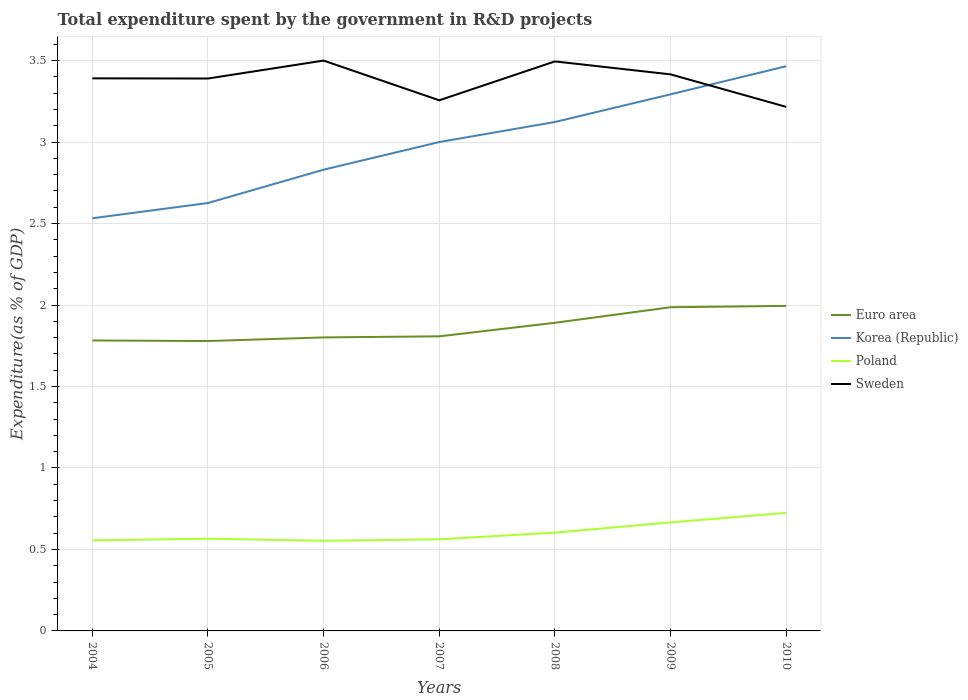How many different coloured lines are there?
Ensure brevity in your answer.  4. Does the line corresponding to Sweden intersect with the line corresponding to Poland?
Your response must be concise. No. Is the number of lines equal to the number of legend labels?
Offer a very short reply. Yes. Across all years, what is the maximum total expenditure spent by the government in R&D projects in Korea (Republic)?
Make the answer very short. 2.53. In which year was the total expenditure spent by the government in R&D projects in Euro area maximum?
Give a very brief answer. 2005. What is the total total expenditure spent by the government in R&D projects in Korea (Republic) in the graph?
Offer a very short reply. -0.17. What is the difference between the highest and the second highest total expenditure spent by the government in R&D projects in Euro area?
Your answer should be compact. 0.22. What is the difference between the highest and the lowest total expenditure spent by the government in R&D projects in Sweden?
Provide a short and direct response. 5. Is the total expenditure spent by the government in R&D projects in Korea (Republic) strictly greater than the total expenditure spent by the government in R&D projects in Sweden over the years?
Make the answer very short. No. How many lines are there?
Make the answer very short. 4. Does the graph contain grids?
Make the answer very short. Yes. Where does the legend appear in the graph?
Offer a terse response. Center right. How many legend labels are there?
Your response must be concise. 4. What is the title of the graph?
Keep it short and to the point. Total expenditure spent by the government in R&D projects. Does "East Asia (developing only)" appear as one of the legend labels in the graph?
Provide a short and direct response. No. What is the label or title of the X-axis?
Ensure brevity in your answer.  Years. What is the label or title of the Y-axis?
Keep it short and to the point. Expenditure(as % of GDP). What is the Expenditure(as % of GDP) in Euro area in 2004?
Ensure brevity in your answer.  1.78. What is the Expenditure(as % of GDP) in Korea (Republic) in 2004?
Your answer should be very brief. 2.53. What is the Expenditure(as % of GDP) in Poland in 2004?
Keep it short and to the point. 0.56. What is the Expenditure(as % of GDP) in Sweden in 2004?
Your answer should be compact. 3.39. What is the Expenditure(as % of GDP) in Euro area in 2005?
Keep it short and to the point. 1.78. What is the Expenditure(as % of GDP) of Korea (Republic) in 2005?
Offer a very short reply. 2.63. What is the Expenditure(as % of GDP) in Poland in 2005?
Offer a terse response. 0.57. What is the Expenditure(as % of GDP) of Sweden in 2005?
Provide a short and direct response. 3.39. What is the Expenditure(as % of GDP) of Euro area in 2006?
Your response must be concise. 1.8. What is the Expenditure(as % of GDP) of Korea (Republic) in 2006?
Make the answer very short. 2.83. What is the Expenditure(as % of GDP) of Poland in 2006?
Give a very brief answer. 0.55. What is the Expenditure(as % of GDP) of Sweden in 2006?
Provide a succinct answer. 3.5. What is the Expenditure(as % of GDP) in Euro area in 2007?
Your answer should be very brief. 1.81. What is the Expenditure(as % of GDP) of Korea (Republic) in 2007?
Offer a very short reply. 3. What is the Expenditure(as % of GDP) in Poland in 2007?
Your answer should be very brief. 0.56. What is the Expenditure(as % of GDP) in Sweden in 2007?
Keep it short and to the point. 3.26. What is the Expenditure(as % of GDP) in Euro area in 2008?
Provide a succinct answer. 1.89. What is the Expenditure(as % of GDP) of Korea (Republic) in 2008?
Make the answer very short. 3.12. What is the Expenditure(as % of GDP) in Poland in 2008?
Provide a succinct answer. 0.6. What is the Expenditure(as % of GDP) of Sweden in 2008?
Provide a succinct answer. 3.5. What is the Expenditure(as % of GDP) of Euro area in 2009?
Give a very brief answer. 1.99. What is the Expenditure(as % of GDP) of Korea (Republic) in 2009?
Your answer should be very brief. 3.29. What is the Expenditure(as % of GDP) in Poland in 2009?
Provide a short and direct response. 0.67. What is the Expenditure(as % of GDP) in Sweden in 2009?
Make the answer very short. 3.42. What is the Expenditure(as % of GDP) in Euro area in 2010?
Provide a short and direct response. 1.99. What is the Expenditure(as % of GDP) of Korea (Republic) in 2010?
Keep it short and to the point. 3.47. What is the Expenditure(as % of GDP) in Poland in 2010?
Give a very brief answer. 0.72. What is the Expenditure(as % of GDP) in Sweden in 2010?
Your answer should be compact. 3.22. Across all years, what is the maximum Expenditure(as % of GDP) in Euro area?
Your answer should be compact. 1.99. Across all years, what is the maximum Expenditure(as % of GDP) of Korea (Republic)?
Your answer should be very brief. 3.47. Across all years, what is the maximum Expenditure(as % of GDP) of Poland?
Your answer should be very brief. 0.72. Across all years, what is the maximum Expenditure(as % of GDP) of Sweden?
Offer a terse response. 3.5. Across all years, what is the minimum Expenditure(as % of GDP) in Euro area?
Offer a very short reply. 1.78. Across all years, what is the minimum Expenditure(as % of GDP) of Korea (Republic)?
Your answer should be compact. 2.53. Across all years, what is the minimum Expenditure(as % of GDP) of Poland?
Give a very brief answer. 0.55. Across all years, what is the minimum Expenditure(as % of GDP) of Sweden?
Give a very brief answer. 3.22. What is the total Expenditure(as % of GDP) in Euro area in the graph?
Your answer should be very brief. 13.04. What is the total Expenditure(as % of GDP) in Korea (Republic) in the graph?
Provide a succinct answer. 20.87. What is the total Expenditure(as % of GDP) in Poland in the graph?
Make the answer very short. 4.23. What is the total Expenditure(as % of GDP) of Sweden in the graph?
Offer a very short reply. 23.67. What is the difference between the Expenditure(as % of GDP) in Euro area in 2004 and that in 2005?
Your answer should be compact. 0. What is the difference between the Expenditure(as % of GDP) in Korea (Republic) in 2004 and that in 2005?
Give a very brief answer. -0.09. What is the difference between the Expenditure(as % of GDP) of Poland in 2004 and that in 2005?
Give a very brief answer. -0.01. What is the difference between the Expenditure(as % of GDP) in Sweden in 2004 and that in 2005?
Your response must be concise. 0. What is the difference between the Expenditure(as % of GDP) of Euro area in 2004 and that in 2006?
Make the answer very short. -0.02. What is the difference between the Expenditure(as % of GDP) in Korea (Republic) in 2004 and that in 2006?
Offer a very short reply. -0.3. What is the difference between the Expenditure(as % of GDP) in Poland in 2004 and that in 2006?
Provide a short and direct response. 0. What is the difference between the Expenditure(as % of GDP) of Sweden in 2004 and that in 2006?
Give a very brief answer. -0.11. What is the difference between the Expenditure(as % of GDP) in Euro area in 2004 and that in 2007?
Offer a very short reply. -0.03. What is the difference between the Expenditure(as % of GDP) of Korea (Republic) in 2004 and that in 2007?
Provide a short and direct response. -0.47. What is the difference between the Expenditure(as % of GDP) in Poland in 2004 and that in 2007?
Your response must be concise. -0.01. What is the difference between the Expenditure(as % of GDP) in Sweden in 2004 and that in 2007?
Provide a succinct answer. 0.13. What is the difference between the Expenditure(as % of GDP) of Euro area in 2004 and that in 2008?
Provide a short and direct response. -0.11. What is the difference between the Expenditure(as % of GDP) of Korea (Republic) in 2004 and that in 2008?
Your answer should be very brief. -0.59. What is the difference between the Expenditure(as % of GDP) in Poland in 2004 and that in 2008?
Offer a very short reply. -0.05. What is the difference between the Expenditure(as % of GDP) of Sweden in 2004 and that in 2008?
Offer a terse response. -0.1. What is the difference between the Expenditure(as % of GDP) in Euro area in 2004 and that in 2009?
Your answer should be compact. -0.2. What is the difference between the Expenditure(as % of GDP) in Korea (Republic) in 2004 and that in 2009?
Provide a succinct answer. -0.76. What is the difference between the Expenditure(as % of GDP) in Poland in 2004 and that in 2009?
Offer a very short reply. -0.11. What is the difference between the Expenditure(as % of GDP) of Sweden in 2004 and that in 2009?
Your answer should be very brief. -0.02. What is the difference between the Expenditure(as % of GDP) in Euro area in 2004 and that in 2010?
Offer a terse response. -0.21. What is the difference between the Expenditure(as % of GDP) of Korea (Republic) in 2004 and that in 2010?
Ensure brevity in your answer.  -0.93. What is the difference between the Expenditure(as % of GDP) of Poland in 2004 and that in 2010?
Make the answer very short. -0.17. What is the difference between the Expenditure(as % of GDP) of Sweden in 2004 and that in 2010?
Offer a very short reply. 0.18. What is the difference between the Expenditure(as % of GDP) of Euro area in 2005 and that in 2006?
Your answer should be very brief. -0.02. What is the difference between the Expenditure(as % of GDP) of Korea (Republic) in 2005 and that in 2006?
Keep it short and to the point. -0.2. What is the difference between the Expenditure(as % of GDP) of Poland in 2005 and that in 2006?
Keep it short and to the point. 0.01. What is the difference between the Expenditure(as % of GDP) in Sweden in 2005 and that in 2006?
Your answer should be very brief. -0.11. What is the difference between the Expenditure(as % of GDP) in Euro area in 2005 and that in 2007?
Provide a short and direct response. -0.03. What is the difference between the Expenditure(as % of GDP) in Korea (Republic) in 2005 and that in 2007?
Offer a very short reply. -0.37. What is the difference between the Expenditure(as % of GDP) in Poland in 2005 and that in 2007?
Give a very brief answer. 0. What is the difference between the Expenditure(as % of GDP) in Sweden in 2005 and that in 2007?
Make the answer very short. 0.13. What is the difference between the Expenditure(as % of GDP) in Euro area in 2005 and that in 2008?
Your answer should be compact. -0.11. What is the difference between the Expenditure(as % of GDP) of Korea (Republic) in 2005 and that in 2008?
Your answer should be compact. -0.5. What is the difference between the Expenditure(as % of GDP) in Poland in 2005 and that in 2008?
Give a very brief answer. -0.04. What is the difference between the Expenditure(as % of GDP) of Sweden in 2005 and that in 2008?
Offer a very short reply. -0.1. What is the difference between the Expenditure(as % of GDP) in Euro area in 2005 and that in 2009?
Offer a terse response. -0.21. What is the difference between the Expenditure(as % of GDP) in Korea (Republic) in 2005 and that in 2009?
Your answer should be very brief. -0.67. What is the difference between the Expenditure(as % of GDP) of Sweden in 2005 and that in 2009?
Offer a terse response. -0.03. What is the difference between the Expenditure(as % of GDP) in Euro area in 2005 and that in 2010?
Make the answer very short. -0.22. What is the difference between the Expenditure(as % of GDP) in Korea (Republic) in 2005 and that in 2010?
Ensure brevity in your answer.  -0.84. What is the difference between the Expenditure(as % of GDP) of Poland in 2005 and that in 2010?
Offer a terse response. -0.16. What is the difference between the Expenditure(as % of GDP) in Sweden in 2005 and that in 2010?
Your response must be concise. 0.17. What is the difference between the Expenditure(as % of GDP) in Euro area in 2006 and that in 2007?
Offer a terse response. -0.01. What is the difference between the Expenditure(as % of GDP) in Korea (Republic) in 2006 and that in 2007?
Provide a short and direct response. -0.17. What is the difference between the Expenditure(as % of GDP) in Poland in 2006 and that in 2007?
Offer a very short reply. -0.01. What is the difference between the Expenditure(as % of GDP) in Sweden in 2006 and that in 2007?
Provide a short and direct response. 0.24. What is the difference between the Expenditure(as % of GDP) in Euro area in 2006 and that in 2008?
Your answer should be compact. -0.09. What is the difference between the Expenditure(as % of GDP) in Korea (Republic) in 2006 and that in 2008?
Provide a succinct answer. -0.29. What is the difference between the Expenditure(as % of GDP) of Poland in 2006 and that in 2008?
Keep it short and to the point. -0.05. What is the difference between the Expenditure(as % of GDP) of Sweden in 2006 and that in 2008?
Provide a succinct answer. 0.01. What is the difference between the Expenditure(as % of GDP) of Euro area in 2006 and that in 2009?
Offer a very short reply. -0.19. What is the difference between the Expenditure(as % of GDP) in Korea (Republic) in 2006 and that in 2009?
Give a very brief answer. -0.46. What is the difference between the Expenditure(as % of GDP) of Poland in 2006 and that in 2009?
Offer a very short reply. -0.11. What is the difference between the Expenditure(as % of GDP) of Sweden in 2006 and that in 2009?
Give a very brief answer. 0.08. What is the difference between the Expenditure(as % of GDP) in Euro area in 2006 and that in 2010?
Provide a succinct answer. -0.19. What is the difference between the Expenditure(as % of GDP) in Korea (Republic) in 2006 and that in 2010?
Provide a succinct answer. -0.64. What is the difference between the Expenditure(as % of GDP) of Poland in 2006 and that in 2010?
Offer a terse response. -0.17. What is the difference between the Expenditure(as % of GDP) in Sweden in 2006 and that in 2010?
Offer a terse response. 0.28. What is the difference between the Expenditure(as % of GDP) of Euro area in 2007 and that in 2008?
Ensure brevity in your answer.  -0.08. What is the difference between the Expenditure(as % of GDP) of Korea (Republic) in 2007 and that in 2008?
Offer a terse response. -0.12. What is the difference between the Expenditure(as % of GDP) of Poland in 2007 and that in 2008?
Provide a short and direct response. -0.04. What is the difference between the Expenditure(as % of GDP) in Sweden in 2007 and that in 2008?
Your answer should be very brief. -0.24. What is the difference between the Expenditure(as % of GDP) in Euro area in 2007 and that in 2009?
Provide a short and direct response. -0.18. What is the difference between the Expenditure(as % of GDP) in Korea (Republic) in 2007 and that in 2009?
Offer a terse response. -0.29. What is the difference between the Expenditure(as % of GDP) of Poland in 2007 and that in 2009?
Make the answer very short. -0.1. What is the difference between the Expenditure(as % of GDP) of Sweden in 2007 and that in 2009?
Offer a very short reply. -0.16. What is the difference between the Expenditure(as % of GDP) in Euro area in 2007 and that in 2010?
Ensure brevity in your answer.  -0.19. What is the difference between the Expenditure(as % of GDP) in Korea (Republic) in 2007 and that in 2010?
Your answer should be very brief. -0.47. What is the difference between the Expenditure(as % of GDP) of Poland in 2007 and that in 2010?
Offer a very short reply. -0.16. What is the difference between the Expenditure(as % of GDP) of Sweden in 2007 and that in 2010?
Give a very brief answer. 0.04. What is the difference between the Expenditure(as % of GDP) in Euro area in 2008 and that in 2009?
Your response must be concise. -0.1. What is the difference between the Expenditure(as % of GDP) of Korea (Republic) in 2008 and that in 2009?
Provide a short and direct response. -0.17. What is the difference between the Expenditure(as % of GDP) in Poland in 2008 and that in 2009?
Offer a very short reply. -0.06. What is the difference between the Expenditure(as % of GDP) in Sweden in 2008 and that in 2009?
Ensure brevity in your answer.  0.08. What is the difference between the Expenditure(as % of GDP) in Euro area in 2008 and that in 2010?
Offer a terse response. -0.1. What is the difference between the Expenditure(as % of GDP) of Korea (Republic) in 2008 and that in 2010?
Ensure brevity in your answer.  -0.34. What is the difference between the Expenditure(as % of GDP) of Poland in 2008 and that in 2010?
Provide a succinct answer. -0.12. What is the difference between the Expenditure(as % of GDP) of Sweden in 2008 and that in 2010?
Your response must be concise. 0.28. What is the difference between the Expenditure(as % of GDP) in Euro area in 2009 and that in 2010?
Provide a succinct answer. -0.01. What is the difference between the Expenditure(as % of GDP) in Korea (Republic) in 2009 and that in 2010?
Ensure brevity in your answer.  -0.17. What is the difference between the Expenditure(as % of GDP) in Poland in 2009 and that in 2010?
Your answer should be compact. -0.06. What is the difference between the Expenditure(as % of GDP) in Sweden in 2009 and that in 2010?
Offer a very short reply. 0.2. What is the difference between the Expenditure(as % of GDP) in Euro area in 2004 and the Expenditure(as % of GDP) in Korea (Republic) in 2005?
Your answer should be compact. -0.84. What is the difference between the Expenditure(as % of GDP) of Euro area in 2004 and the Expenditure(as % of GDP) of Poland in 2005?
Offer a very short reply. 1.22. What is the difference between the Expenditure(as % of GDP) of Euro area in 2004 and the Expenditure(as % of GDP) of Sweden in 2005?
Ensure brevity in your answer.  -1.61. What is the difference between the Expenditure(as % of GDP) of Korea (Republic) in 2004 and the Expenditure(as % of GDP) of Poland in 2005?
Your answer should be very brief. 1.97. What is the difference between the Expenditure(as % of GDP) of Korea (Republic) in 2004 and the Expenditure(as % of GDP) of Sweden in 2005?
Give a very brief answer. -0.86. What is the difference between the Expenditure(as % of GDP) of Poland in 2004 and the Expenditure(as % of GDP) of Sweden in 2005?
Ensure brevity in your answer.  -2.83. What is the difference between the Expenditure(as % of GDP) of Euro area in 2004 and the Expenditure(as % of GDP) of Korea (Republic) in 2006?
Offer a terse response. -1.05. What is the difference between the Expenditure(as % of GDP) of Euro area in 2004 and the Expenditure(as % of GDP) of Poland in 2006?
Give a very brief answer. 1.23. What is the difference between the Expenditure(as % of GDP) of Euro area in 2004 and the Expenditure(as % of GDP) of Sweden in 2006?
Provide a short and direct response. -1.72. What is the difference between the Expenditure(as % of GDP) of Korea (Republic) in 2004 and the Expenditure(as % of GDP) of Poland in 2006?
Give a very brief answer. 1.98. What is the difference between the Expenditure(as % of GDP) in Korea (Republic) in 2004 and the Expenditure(as % of GDP) in Sweden in 2006?
Keep it short and to the point. -0.97. What is the difference between the Expenditure(as % of GDP) of Poland in 2004 and the Expenditure(as % of GDP) of Sweden in 2006?
Offer a very short reply. -2.94. What is the difference between the Expenditure(as % of GDP) in Euro area in 2004 and the Expenditure(as % of GDP) in Korea (Republic) in 2007?
Your answer should be compact. -1.22. What is the difference between the Expenditure(as % of GDP) of Euro area in 2004 and the Expenditure(as % of GDP) of Poland in 2007?
Provide a short and direct response. 1.22. What is the difference between the Expenditure(as % of GDP) of Euro area in 2004 and the Expenditure(as % of GDP) of Sweden in 2007?
Your answer should be very brief. -1.47. What is the difference between the Expenditure(as % of GDP) of Korea (Republic) in 2004 and the Expenditure(as % of GDP) of Poland in 2007?
Your answer should be compact. 1.97. What is the difference between the Expenditure(as % of GDP) of Korea (Republic) in 2004 and the Expenditure(as % of GDP) of Sweden in 2007?
Offer a terse response. -0.72. What is the difference between the Expenditure(as % of GDP) of Poland in 2004 and the Expenditure(as % of GDP) of Sweden in 2007?
Provide a short and direct response. -2.7. What is the difference between the Expenditure(as % of GDP) of Euro area in 2004 and the Expenditure(as % of GDP) of Korea (Republic) in 2008?
Offer a terse response. -1.34. What is the difference between the Expenditure(as % of GDP) of Euro area in 2004 and the Expenditure(as % of GDP) of Poland in 2008?
Ensure brevity in your answer.  1.18. What is the difference between the Expenditure(as % of GDP) in Euro area in 2004 and the Expenditure(as % of GDP) in Sweden in 2008?
Offer a very short reply. -1.71. What is the difference between the Expenditure(as % of GDP) in Korea (Republic) in 2004 and the Expenditure(as % of GDP) in Poland in 2008?
Your response must be concise. 1.93. What is the difference between the Expenditure(as % of GDP) of Korea (Republic) in 2004 and the Expenditure(as % of GDP) of Sweden in 2008?
Provide a succinct answer. -0.96. What is the difference between the Expenditure(as % of GDP) of Poland in 2004 and the Expenditure(as % of GDP) of Sweden in 2008?
Provide a succinct answer. -2.94. What is the difference between the Expenditure(as % of GDP) in Euro area in 2004 and the Expenditure(as % of GDP) in Korea (Republic) in 2009?
Your answer should be compact. -1.51. What is the difference between the Expenditure(as % of GDP) of Euro area in 2004 and the Expenditure(as % of GDP) of Poland in 2009?
Make the answer very short. 1.12. What is the difference between the Expenditure(as % of GDP) in Euro area in 2004 and the Expenditure(as % of GDP) in Sweden in 2009?
Offer a terse response. -1.63. What is the difference between the Expenditure(as % of GDP) of Korea (Republic) in 2004 and the Expenditure(as % of GDP) of Poland in 2009?
Provide a short and direct response. 1.87. What is the difference between the Expenditure(as % of GDP) of Korea (Republic) in 2004 and the Expenditure(as % of GDP) of Sweden in 2009?
Your response must be concise. -0.88. What is the difference between the Expenditure(as % of GDP) in Poland in 2004 and the Expenditure(as % of GDP) in Sweden in 2009?
Your answer should be compact. -2.86. What is the difference between the Expenditure(as % of GDP) of Euro area in 2004 and the Expenditure(as % of GDP) of Korea (Republic) in 2010?
Provide a succinct answer. -1.68. What is the difference between the Expenditure(as % of GDP) of Euro area in 2004 and the Expenditure(as % of GDP) of Poland in 2010?
Keep it short and to the point. 1.06. What is the difference between the Expenditure(as % of GDP) of Euro area in 2004 and the Expenditure(as % of GDP) of Sweden in 2010?
Ensure brevity in your answer.  -1.43. What is the difference between the Expenditure(as % of GDP) of Korea (Republic) in 2004 and the Expenditure(as % of GDP) of Poland in 2010?
Your response must be concise. 1.81. What is the difference between the Expenditure(as % of GDP) in Korea (Republic) in 2004 and the Expenditure(as % of GDP) in Sweden in 2010?
Your response must be concise. -0.68. What is the difference between the Expenditure(as % of GDP) of Poland in 2004 and the Expenditure(as % of GDP) of Sweden in 2010?
Make the answer very short. -2.66. What is the difference between the Expenditure(as % of GDP) of Euro area in 2005 and the Expenditure(as % of GDP) of Korea (Republic) in 2006?
Your response must be concise. -1.05. What is the difference between the Expenditure(as % of GDP) of Euro area in 2005 and the Expenditure(as % of GDP) of Poland in 2006?
Ensure brevity in your answer.  1.23. What is the difference between the Expenditure(as % of GDP) in Euro area in 2005 and the Expenditure(as % of GDP) in Sweden in 2006?
Your answer should be compact. -1.72. What is the difference between the Expenditure(as % of GDP) of Korea (Republic) in 2005 and the Expenditure(as % of GDP) of Poland in 2006?
Provide a short and direct response. 2.07. What is the difference between the Expenditure(as % of GDP) of Korea (Republic) in 2005 and the Expenditure(as % of GDP) of Sweden in 2006?
Offer a terse response. -0.87. What is the difference between the Expenditure(as % of GDP) of Poland in 2005 and the Expenditure(as % of GDP) of Sweden in 2006?
Keep it short and to the point. -2.93. What is the difference between the Expenditure(as % of GDP) in Euro area in 2005 and the Expenditure(as % of GDP) in Korea (Republic) in 2007?
Make the answer very short. -1.22. What is the difference between the Expenditure(as % of GDP) in Euro area in 2005 and the Expenditure(as % of GDP) in Poland in 2007?
Your answer should be compact. 1.22. What is the difference between the Expenditure(as % of GDP) of Euro area in 2005 and the Expenditure(as % of GDP) of Sweden in 2007?
Offer a terse response. -1.48. What is the difference between the Expenditure(as % of GDP) in Korea (Republic) in 2005 and the Expenditure(as % of GDP) in Poland in 2007?
Ensure brevity in your answer.  2.06. What is the difference between the Expenditure(as % of GDP) in Korea (Republic) in 2005 and the Expenditure(as % of GDP) in Sweden in 2007?
Provide a short and direct response. -0.63. What is the difference between the Expenditure(as % of GDP) of Poland in 2005 and the Expenditure(as % of GDP) of Sweden in 2007?
Keep it short and to the point. -2.69. What is the difference between the Expenditure(as % of GDP) of Euro area in 2005 and the Expenditure(as % of GDP) of Korea (Republic) in 2008?
Make the answer very short. -1.34. What is the difference between the Expenditure(as % of GDP) of Euro area in 2005 and the Expenditure(as % of GDP) of Poland in 2008?
Provide a succinct answer. 1.18. What is the difference between the Expenditure(as % of GDP) in Euro area in 2005 and the Expenditure(as % of GDP) in Sweden in 2008?
Keep it short and to the point. -1.72. What is the difference between the Expenditure(as % of GDP) of Korea (Republic) in 2005 and the Expenditure(as % of GDP) of Poland in 2008?
Your response must be concise. 2.02. What is the difference between the Expenditure(as % of GDP) in Korea (Republic) in 2005 and the Expenditure(as % of GDP) in Sweden in 2008?
Make the answer very short. -0.87. What is the difference between the Expenditure(as % of GDP) of Poland in 2005 and the Expenditure(as % of GDP) of Sweden in 2008?
Give a very brief answer. -2.93. What is the difference between the Expenditure(as % of GDP) in Euro area in 2005 and the Expenditure(as % of GDP) in Korea (Republic) in 2009?
Make the answer very short. -1.51. What is the difference between the Expenditure(as % of GDP) of Euro area in 2005 and the Expenditure(as % of GDP) of Poland in 2009?
Give a very brief answer. 1.11. What is the difference between the Expenditure(as % of GDP) of Euro area in 2005 and the Expenditure(as % of GDP) of Sweden in 2009?
Your answer should be very brief. -1.64. What is the difference between the Expenditure(as % of GDP) in Korea (Republic) in 2005 and the Expenditure(as % of GDP) in Poland in 2009?
Keep it short and to the point. 1.96. What is the difference between the Expenditure(as % of GDP) in Korea (Republic) in 2005 and the Expenditure(as % of GDP) in Sweden in 2009?
Give a very brief answer. -0.79. What is the difference between the Expenditure(as % of GDP) of Poland in 2005 and the Expenditure(as % of GDP) of Sweden in 2009?
Make the answer very short. -2.85. What is the difference between the Expenditure(as % of GDP) in Euro area in 2005 and the Expenditure(as % of GDP) in Korea (Republic) in 2010?
Provide a succinct answer. -1.69. What is the difference between the Expenditure(as % of GDP) in Euro area in 2005 and the Expenditure(as % of GDP) in Poland in 2010?
Make the answer very short. 1.05. What is the difference between the Expenditure(as % of GDP) in Euro area in 2005 and the Expenditure(as % of GDP) in Sweden in 2010?
Provide a succinct answer. -1.44. What is the difference between the Expenditure(as % of GDP) of Korea (Republic) in 2005 and the Expenditure(as % of GDP) of Poland in 2010?
Give a very brief answer. 1.9. What is the difference between the Expenditure(as % of GDP) of Korea (Republic) in 2005 and the Expenditure(as % of GDP) of Sweden in 2010?
Offer a very short reply. -0.59. What is the difference between the Expenditure(as % of GDP) of Poland in 2005 and the Expenditure(as % of GDP) of Sweden in 2010?
Provide a succinct answer. -2.65. What is the difference between the Expenditure(as % of GDP) of Euro area in 2006 and the Expenditure(as % of GDP) of Korea (Republic) in 2007?
Make the answer very short. -1.2. What is the difference between the Expenditure(as % of GDP) of Euro area in 2006 and the Expenditure(as % of GDP) of Poland in 2007?
Provide a short and direct response. 1.24. What is the difference between the Expenditure(as % of GDP) of Euro area in 2006 and the Expenditure(as % of GDP) of Sweden in 2007?
Provide a succinct answer. -1.46. What is the difference between the Expenditure(as % of GDP) in Korea (Republic) in 2006 and the Expenditure(as % of GDP) in Poland in 2007?
Offer a very short reply. 2.27. What is the difference between the Expenditure(as % of GDP) in Korea (Republic) in 2006 and the Expenditure(as % of GDP) in Sweden in 2007?
Provide a short and direct response. -0.43. What is the difference between the Expenditure(as % of GDP) in Poland in 2006 and the Expenditure(as % of GDP) in Sweden in 2007?
Offer a very short reply. -2.7. What is the difference between the Expenditure(as % of GDP) in Euro area in 2006 and the Expenditure(as % of GDP) in Korea (Republic) in 2008?
Ensure brevity in your answer.  -1.32. What is the difference between the Expenditure(as % of GDP) in Euro area in 2006 and the Expenditure(as % of GDP) in Poland in 2008?
Your response must be concise. 1.2. What is the difference between the Expenditure(as % of GDP) in Euro area in 2006 and the Expenditure(as % of GDP) in Sweden in 2008?
Provide a short and direct response. -1.69. What is the difference between the Expenditure(as % of GDP) in Korea (Republic) in 2006 and the Expenditure(as % of GDP) in Poland in 2008?
Keep it short and to the point. 2.23. What is the difference between the Expenditure(as % of GDP) of Korea (Republic) in 2006 and the Expenditure(as % of GDP) of Sweden in 2008?
Offer a terse response. -0.66. What is the difference between the Expenditure(as % of GDP) of Poland in 2006 and the Expenditure(as % of GDP) of Sweden in 2008?
Your response must be concise. -2.94. What is the difference between the Expenditure(as % of GDP) of Euro area in 2006 and the Expenditure(as % of GDP) of Korea (Republic) in 2009?
Provide a succinct answer. -1.49. What is the difference between the Expenditure(as % of GDP) in Euro area in 2006 and the Expenditure(as % of GDP) in Poland in 2009?
Your answer should be compact. 1.14. What is the difference between the Expenditure(as % of GDP) of Euro area in 2006 and the Expenditure(as % of GDP) of Sweden in 2009?
Make the answer very short. -1.61. What is the difference between the Expenditure(as % of GDP) of Korea (Republic) in 2006 and the Expenditure(as % of GDP) of Poland in 2009?
Give a very brief answer. 2.16. What is the difference between the Expenditure(as % of GDP) in Korea (Republic) in 2006 and the Expenditure(as % of GDP) in Sweden in 2009?
Your answer should be very brief. -0.59. What is the difference between the Expenditure(as % of GDP) of Poland in 2006 and the Expenditure(as % of GDP) of Sweden in 2009?
Offer a very short reply. -2.86. What is the difference between the Expenditure(as % of GDP) in Euro area in 2006 and the Expenditure(as % of GDP) in Korea (Republic) in 2010?
Your response must be concise. -1.66. What is the difference between the Expenditure(as % of GDP) in Euro area in 2006 and the Expenditure(as % of GDP) in Poland in 2010?
Offer a very short reply. 1.08. What is the difference between the Expenditure(as % of GDP) of Euro area in 2006 and the Expenditure(as % of GDP) of Sweden in 2010?
Your answer should be very brief. -1.41. What is the difference between the Expenditure(as % of GDP) in Korea (Republic) in 2006 and the Expenditure(as % of GDP) in Poland in 2010?
Provide a succinct answer. 2.11. What is the difference between the Expenditure(as % of GDP) in Korea (Republic) in 2006 and the Expenditure(as % of GDP) in Sweden in 2010?
Offer a very short reply. -0.39. What is the difference between the Expenditure(as % of GDP) in Poland in 2006 and the Expenditure(as % of GDP) in Sweden in 2010?
Keep it short and to the point. -2.66. What is the difference between the Expenditure(as % of GDP) of Euro area in 2007 and the Expenditure(as % of GDP) of Korea (Republic) in 2008?
Your response must be concise. -1.32. What is the difference between the Expenditure(as % of GDP) of Euro area in 2007 and the Expenditure(as % of GDP) of Poland in 2008?
Your answer should be very brief. 1.2. What is the difference between the Expenditure(as % of GDP) of Euro area in 2007 and the Expenditure(as % of GDP) of Sweden in 2008?
Your answer should be compact. -1.69. What is the difference between the Expenditure(as % of GDP) of Korea (Republic) in 2007 and the Expenditure(as % of GDP) of Poland in 2008?
Your answer should be very brief. 2.4. What is the difference between the Expenditure(as % of GDP) of Korea (Republic) in 2007 and the Expenditure(as % of GDP) of Sweden in 2008?
Your answer should be very brief. -0.49. What is the difference between the Expenditure(as % of GDP) of Poland in 2007 and the Expenditure(as % of GDP) of Sweden in 2008?
Your response must be concise. -2.93. What is the difference between the Expenditure(as % of GDP) in Euro area in 2007 and the Expenditure(as % of GDP) in Korea (Republic) in 2009?
Give a very brief answer. -1.49. What is the difference between the Expenditure(as % of GDP) of Euro area in 2007 and the Expenditure(as % of GDP) of Poland in 2009?
Give a very brief answer. 1.14. What is the difference between the Expenditure(as % of GDP) of Euro area in 2007 and the Expenditure(as % of GDP) of Sweden in 2009?
Offer a terse response. -1.61. What is the difference between the Expenditure(as % of GDP) in Korea (Republic) in 2007 and the Expenditure(as % of GDP) in Poland in 2009?
Provide a succinct answer. 2.33. What is the difference between the Expenditure(as % of GDP) of Korea (Republic) in 2007 and the Expenditure(as % of GDP) of Sweden in 2009?
Ensure brevity in your answer.  -0.42. What is the difference between the Expenditure(as % of GDP) of Poland in 2007 and the Expenditure(as % of GDP) of Sweden in 2009?
Ensure brevity in your answer.  -2.85. What is the difference between the Expenditure(as % of GDP) in Euro area in 2007 and the Expenditure(as % of GDP) in Korea (Republic) in 2010?
Offer a very short reply. -1.66. What is the difference between the Expenditure(as % of GDP) in Euro area in 2007 and the Expenditure(as % of GDP) in Sweden in 2010?
Your answer should be very brief. -1.41. What is the difference between the Expenditure(as % of GDP) in Korea (Republic) in 2007 and the Expenditure(as % of GDP) in Poland in 2010?
Provide a short and direct response. 2.28. What is the difference between the Expenditure(as % of GDP) of Korea (Republic) in 2007 and the Expenditure(as % of GDP) of Sweden in 2010?
Your response must be concise. -0.22. What is the difference between the Expenditure(as % of GDP) of Poland in 2007 and the Expenditure(as % of GDP) of Sweden in 2010?
Your answer should be compact. -2.65. What is the difference between the Expenditure(as % of GDP) of Euro area in 2008 and the Expenditure(as % of GDP) of Korea (Republic) in 2009?
Give a very brief answer. -1.4. What is the difference between the Expenditure(as % of GDP) in Euro area in 2008 and the Expenditure(as % of GDP) in Poland in 2009?
Your answer should be compact. 1.23. What is the difference between the Expenditure(as % of GDP) in Euro area in 2008 and the Expenditure(as % of GDP) in Sweden in 2009?
Offer a very short reply. -1.52. What is the difference between the Expenditure(as % of GDP) of Korea (Republic) in 2008 and the Expenditure(as % of GDP) of Poland in 2009?
Offer a terse response. 2.46. What is the difference between the Expenditure(as % of GDP) in Korea (Republic) in 2008 and the Expenditure(as % of GDP) in Sweden in 2009?
Give a very brief answer. -0.29. What is the difference between the Expenditure(as % of GDP) of Poland in 2008 and the Expenditure(as % of GDP) of Sweden in 2009?
Give a very brief answer. -2.81. What is the difference between the Expenditure(as % of GDP) of Euro area in 2008 and the Expenditure(as % of GDP) of Korea (Republic) in 2010?
Your answer should be compact. -1.57. What is the difference between the Expenditure(as % of GDP) of Euro area in 2008 and the Expenditure(as % of GDP) of Poland in 2010?
Your answer should be very brief. 1.17. What is the difference between the Expenditure(as % of GDP) of Euro area in 2008 and the Expenditure(as % of GDP) of Sweden in 2010?
Ensure brevity in your answer.  -1.32. What is the difference between the Expenditure(as % of GDP) in Korea (Republic) in 2008 and the Expenditure(as % of GDP) in Poland in 2010?
Provide a short and direct response. 2.4. What is the difference between the Expenditure(as % of GDP) of Korea (Republic) in 2008 and the Expenditure(as % of GDP) of Sweden in 2010?
Provide a succinct answer. -0.09. What is the difference between the Expenditure(as % of GDP) in Poland in 2008 and the Expenditure(as % of GDP) in Sweden in 2010?
Make the answer very short. -2.61. What is the difference between the Expenditure(as % of GDP) in Euro area in 2009 and the Expenditure(as % of GDP) in Korea (Republic) in 2010?
Give a very brief answer. -1.48. What is the difference between the Expenditure(as % of GDP) of Euro area in 2009 and the Expenditure(as % of GDP) of Poland in 2010?
Give a very brief answer. 1.26. What is the difference between the Expenditure(as % of GDP) in Euro area in 2009 and the Expenditure(as % of GDP) in Sweden in 2010?
Give a very brief answer. -1.23. What is the difference between the Expenditure(as % of GDP) of Korea (Republic) in 2009 and the Expenditure(as % of GDP) of Poland in 2010?
Make the answer very short. 2.57. What is the difference between the Expenditure(as % of GDP) in Korea (Republic) in 2009 and the Expenditure(as % of GDP) in Sweden in 2010?
Your answer should be compact. 0.08. What is the difference between the Expenditure(as % of GDP) in Poland in 2009 and the Expenditure(as % of GDP) in Sweden in 2010?
Provide a short and direct response. -2.55. What is the average Expenditure(as % of GDP) of Euro area per year?
Ensure brevity in your answer.  1.86. What is the average Expenditure(as % of GDP) of Korea (Republic) per year?
Provide a short and direct response. 2.98. What is the average Expenditure(as % of GDP) in Poland per year?
Offer a terse response. 0.6. What is the average Expenditure(as % of GDP) in Sweden per year?
Keep it short and to the point. 3.38. In the year 2004, what is the difference between the Expenditure(as % of GDP) of Euro area and Expenditure(as % of GDP) of Korea (Republic)?
Provide a succinct answer. -0.75. In the year 2004, what is the difference between the Expenditure(as % of GDP) in Euro area and Expenditure(as % of GDP) in Poland?
Offer a terse response. 1.23. In the year 2004, what is the difference between the Expenditure(as % of GDP) of Euro area and Expenditure(as % of GDP) of Sweden?
Offer a terse response. -1.61. In the year 2004, what is the difference between the Expenditure(as % of GDP) of Korea (Republic) and Expenditure(as % of GDP) of Poland?
Ensure brevity in your answer.  1.98. In the year 2004, what is the difference between the Expenditure(as % of GDP) of Korea (Republic) and Expenditure(as % of GDP) of Sweden?
Your answer should be compact. -0.86. In the year 2004, what is the difference between the Expenditure(as % of GDP) of Poland and Expenditure(as % of GDP) of Sweden?
Offer a terse response. -2.84. In the year 2005, what is the difference between the Expenditure(as % of GDP) of Euro area and Expenditure(as % of GDP) of Korea (Republic)?
Give a very brief answer. -0.85. In the year 2005, what is the difference between the Expenditure(as % of GDP) of Euro area and Expenditure(as % of GDP) of Poland?
Provide a succinct answer. 1.21. In the year 2005, what is the difference between the Expenditure(as % of GDP) of Euro area and Expenditure(as % of GDP) of Sweden?
Provide a succinct answer. -1.61. In the year 2005, what is the difference between the Expenditure(as % of GDP) of Korea (Republic) and Expenditure(as % of GDP) of Poland?
Your answer should be compact. 2.06. In the year 2005, what is the difference between the Expenditure(as % of GDP) of Korea (Republic) and Expenditure(as % of GDP) of Sweden?
Provide a short and direct response. -0.76. In the year 2005, what is the difference between the Expenditure(as % of GDP) of Poland and Expenditure(as % of GDP) of Sweden?
Ensure brevity in your answer.  -2.82. In the year 2006, what is the difference between the Expenditure(as % of GDP) in Euro area and Expenditure(as % of GDP) in Korea (Republic)?
Provide a short and direct response. -1.03. In the year 2006, what is the difference between the Expenditure(as % of GDP) in Euro area and Expenditure(as % of GDP) in Poland?
Your answer should be very brief. 1.25. In the year 2006, what is the difference between the Expenditure(as % of GDP) of Euro area and Expenditure(as % of GDP) of Sweden?
Your response must be concise. -1.7. In the year 2006, what is the difference between the Expenditure(as % of GDP) in Korea (Republic) and Expenditure(as % of GDP) in Poland?
Your answer should be very brief. 2.28. In the year 2006, what is the difference between the Expenditure(as % of GDP) in Korea (Republic) and Expenditure(as % of GDP) in Sweden?
Give a very brief answer. -0.67. In the year 2006, what is the difference between the Expenditure(as % of GDP) in Poland and Expenditure(as % of GDP) in Sweden?
Ensure brevity in your answer.  -2.95. In the year 2007, what is the difference between the Expenditure(as % of GDP) of Euro area and Expenditure(as % of GDP) of Korea (Republic)?
Your response must be concise. -1.19. In the year 2007, what is the difference between the Expenditure(as % of GDP) of Euro area and Expenditure(as % of GDP) of Poland?
Give a very brief answer. 1.25. In the year 2007, what is the difference between the Expenditure(as % of GDP) in Euro area and Expenditure(as % of GDP) in Sweden?
Your answer should be very brief. -1.45. In the year 2007, what is the difference between the Expenditure(as % of GDP) of Korea (Republic) and Expenditure(as % of GDP) of Poland?
Ensure brevity in your answer.  2.44. In the year 2007, what is the difference between the Expenditure(as % of GDP) of Korea (Republic) and Expenditure(as % of GDP) of Sweden?
Offer a terse response. -0.26. In the year 2007, what is the difference between the Expenditure(as % of GDP) in Poland and Expenditure(as % of GDP) in Sweden?
Offer a very short reply. -2.69. In the year 2008, what is the difference between the Expenditure(as % of GDP) in Euro area and Expenditure(as % of GDP) in Korea (Republic)?
Offer a terse response. -1.23. In the year 2008, what is the difference between the Expenditure(as % of GDP) in Euro area and Expenditure(as % of GDP) in Poland?
Your response must be concise. 1.29. In the year 2008, what is the difference between the Expenditure(as % of GDP) in Euro area and Expenditure(as % of GDP) in Sweden?
Give a very brief answer. -1.6. In the year 2008, what is the difference between the Expenditure(as % of GDP) in Korea (Republic) and Expenditure(as % of GDP) in Poland?
Offer a very short reply. 2.52. In the year 2008, what is the difference between the Expenditure(as % of GDP) of Korea (Republic) and Expenditure(as % of GDP) of Sweden?
Keep it short and to the point. -0.37. In the year 2008, what is the difference between the Expenditure(as % of GDP) in Poland and Expenditure(as % of GDP) in Sweden?
Your answer should be compact. -2.89. In the year 2009, what is the difference between the Expenditure(as % of GDP) of Euro area and Expenditure(as % of GDP) of Korea (Republic)?
Keep it short and to the point. -1.31. In the year 2009, what is the difference between the Expenditure(as % of GDP) in Euro area and Expenditure(as % of GDP) in Poland?
Provide a short and direct response. 1.32. In the year 2009, what is the difference between the Expenditure(as % of GDP) of Euro area and Expenditure(as % of GDP) of Sweden?
Provide a succinct answer. -1.43. In the year 2009, what is the difference between the Expenditure(as % of GDP) of Korea (Republic) and Expenditure(as % of GDP) of Poland?
Offer a very short reply. 2.63. In the year 2009, what is the difference between the Expenditure(as % of GDP) in Korea (Republic) and Expenditure(as % of GDP) in Sweden?
Your response must be concise. -0.12. In the year 2009, what is the difference between the Expenditure(as % of GDP) in Poland and Expenditure(as % of GDP) in Sweden?
Provide a succinct answer. -2.75. In the year 2010, what is the difference between the Expenditure(as % of GDP) in Euro area and Expenditure(as % of GDP) in Korea (Republic)?
Make the answer very short. -1.47. In the year 2010, what is the difference between the Expenditure(as % of GDP) of Euro area and Expenditure(as % of GDP) of Poland?
Offer a terse response. 1.27. In the year 2010, what is the difference between the Expenditure(as % of GDP) of Euro area and Expenditure(as % of GDP) of Sweden?
Give a very brief answer. -1.22. In the year 2010, what is the difference between the Expenditure(as % of GDP) of Korea (Republic) and Expenditure(as % of GDP) of Poland?
Ensure brevity in your answer.  2.74. In the year 2010, what is the difference between the Expenditure(as % of GDP) in Korea (Republic) and Expenditure(as % of GDP) in Sweden?
Ensure brevity in your answer.  0.25. In the year 2010, what is the difference between the Expenditure(as % of GDP) of Poland and Expenditure(as % of GDP) of Sweden?
Offer a very short reply. -2.49. What is the ratio of the Expenditure(as % of GDP) in Euro area in 2004 to that in 2005?
Provide a short and direct response. 1. What is the ratio of the Expenditure(as % of GDP) of Korea (Republic) in 2004 to that in 2005?
Ensure brevity in your answer.  0.96. What is the ratio of the Expenditure(as % of GDP) of Poland in 2004 to that in 2005?
Make the answer very short. 0.98. What is the ratio of the Expenditure(as % of GDP) of Sweden in 2004 to that in 2005?
Offer a terse response. 1. What is the ratio of the Expenditure(as % of GDP) of Euro area in 2004 to that in 2006?
Make the answer very short. 0.99. What is the ratio of the Expenditure(as % of GDP) of Korea (Republic) in 2004 to that in 2006?
Your answer should be compact. 0.89. What is the ratio of the Expenditure(as % of GDP) in Poland in 2004 to that in 2006?
Provide a short and direct response. 1. What is the ratio of the Expenditure(as % of GDP) of Sweden in 2004 to that in 2006?
Ensure brevity in your answer.  0.97. What is the ratio of the Expenditure(as % of GDP) in Korea (Republic) in 2004 to that in 2007?
Keep it short and to the point. 0.84. What is the ratio of the Expenditure(as % of GDP) in Poland in 2004 to that in 2007?
Your answer should be compact. 0.99. What is the ratio of the Expenditure(as % of GDP) of Sweden in 2004 to that in 2007?
Provide a short and direct response. 1.04. What is the ratio of the Expenditure(as % of GDP) of Euro area in 2004 to that in 2008?
Your answer should be compact. 0.94. What is the ratio of the Expenditure(as % of GDP) in Korea (Republic) in 2004 to that in 2008?
Provide a short and direct response. 0.81. What is the ratio of the Expenditure(as % of GDP) of Poland in 2004 to that in 2008?
Make the answer very short. 0.92. What is the ratio of the Expenditure(as % of GDP) in Sweden in 2004 to that in 2008?
Give a very brief answer. 0.97. What is the ratio of the Expenditure(as % of GDP) of Euro area in 2004 to that in 2009?
Your answer should be compact. 0.9. What is the ratio of the Expenditure(as % of GDP) of Korea (Republic) in 2004 to that in 2009?
Ensure brevity in your answer.  0.77. What is the ratio of the Expenditure(as % of GDP) in Poland in 2004 to that in 2009?
Your answer should be compact. 0.83. What is the ratio of the Expenditure(as % of GDP) of Sweden in 2004 to that in 2009?
Provide a short and direct response. 0.99. What is the ratio of the Expenditure(as % of GDP) of Euro area in 2004 to that in 2010?
Give a very brief answer. 0.89. What is the ratio of the Expenditure(as % of GDP) of Korea (Republic) in 2004 to that in 2010?
Your response must be concise. 0.73. What is the ratio of the Expenditure(as % of GDP) of Poland in 2004 to that in 2010?
Your answer should be very brief. 0.77. What is the ratio of the Expenditure(as % of GDP) of Sweden in 2004 to that in 2010?
Keep it short and to the point. 1.05. What is the ratio of the Expenditure(as % of GDP) in Euro area in 2005 to that in 2006?
Offer a terse response. 0.99. What is the ratio of the Expenditure(as % of GDP) in Korea (Republic) in 2005 to that in 2006?
Offer a terse response. 0.93. What is the ratio of the Expenditure(as % of GDP) in Poland in 2005 to that in 2006?
Offer a very short reply. 1.02. What is the ratio of the Expenditure(as % of GDP) of Sweden in 2005 to that in 2006?
Your answer should be compact. 0.97. What is the ratio of the Expenditure(as % of GDP) of Korea (Republic) in 2005 to that in 2007?
Ensure brevity in your answer.  0.88. What is the ratio of the Expenditure(as % of GDP) of Poland in 2005 to that in 2007?
Your answer should be compact. 1.01. What is the ratio of the Expenditure(as % of GDP) of Sweden in 2005 to that in 2007?
Your answer should be very brief. 1.04. What is the ratio of the Expenditure(as % of GDP) of Euro area in 2005 to that in 2008?
Offer a very short reply. 0.94. What is the ratio of the Expenditure(as % of GDP) of Korea (Republic) in 2005 to that in 2008?
Offer a terse response. 0.84. What is the ratio of the Expenditure(as % of GDP) in Poland in 2005 to that in 2008?
Provide a short and direct response. 0.94. What is the ratio of the Expenditure(as % of GDP) of Euro area in 2005 to that in 2009?
Make the answer very short. 0.9. What is the ratio of the Expenditure(as % of GDP) in Korea (Republic) in 2005 to that in 2009?
Your answer should be very brief. 0.8. What is the ratio of the Expenditure(as % of GDP) of Poland in 2005 to that in 2009?
Give a very brief answer. 0.85. What is the ratio of the Expenditure(as % of GDP) of Euro area in 2005 to that in 2010?
Your response must be concise. 0.89. What is the ratio of the Expenditure(as % of GDP) in Korea (Republic) in 2005 to that in 2010?
Your answer should be compact. 0.76. What is the ratio of the Expenditure(as % of GDP) of Poland in 2005 to that in 2010?
Provide a short and direct response. 0.78. What is the ratio of the Expenditure(as % of GDP) in Sweden in 2005 to that in 2010?
Offer a very short reply. 1.05. What is the ratio of the Expenditure(as % of GDP) of Euro area in 2006 to that in 2007?
Your response must be concise. 1. What is the ratio of the Expenditure(as % of GDP) of Korea (Republic) in 2006 to that in 2007?
Provide a short and direct response. 0.94. What is the ratio of the Expenditure(as % of GDP) of Poland in 2006 to that in 2007?
Give a very brief answer. 0.98. What is the ratio of the Expenditure(as % of GDP) in Sweden in 2006 to that in 2007?
Provide a succinct answer. 1.07. What is the ratio of the Expenditure(as % of GDP) of Euro area in 2006 to that in 2008?
Provide a short and direct response. 0.95. What is the ratio of the Expenditure(as % of GDP) in Korea (Republic) in 2006 to that in 2008?
Offer a terse response. 0.91. What is the ratio of the Expenditure(as % of GDP) of Poland in 2006 to that in 2008?
Offer a very short reply. 0.92. What is the ratio of the Expenditure(as % of GDP) in Sweden in 2006 to that in 2008?
Your answer should be very brief. 1. What is the ratio of the Expenditure(as % of GDP) in Euro area in 2006 to that in 2009?
Your answer should be very brief. 0.91. What is the ratio of the Expenditure(as % of GDP) of Korea (Republic) in 2006 to that in 2009?
Offer a very short reply. 0.86. What is the ratio of the Expenditure(as % of GDP) of Poland in 2006 to that in 2009?
Offer a very short reply. 0.83. What is the ratio of the Expenditure(as % of GDP) in Sweden in 2006 to that in 2009?
Offer a terse response. 1.02. What is the ratio of the Expenditure(as % of GDP) of Euro area in 2006 to that in 2010?
Make the answer very short. 0.9. What is the ratio of the Expenditure(as % of GDP) of Korea (Republic) in 2006 to that in 2010?
Offer a terse response. 0.82. What is the ratio of the Expenditure(as % of GDP) of Poland in 2006 to that in 2010?
Ensure brevity in your answer.  0.76. What is the ratio of the Expenditure(as % of GDP) in Sweden in 2006 to that in 2010?
Provide a short and direct response. 1.09. What is the ratio of the Expenditure(as % of GDP) of Euro area in 2007 to that in 2008?
Provide a short and direct response. 0.96. What is the ratio of the Expenditure(as % of GDP) of Korea (Republic) in 2007 to that in 2008?
Offer a very short reply. 0.96. What is the ratio of the Expenditure(as % of GDP) of Poland in 2007 to that in 2008?
Your answer should be compact. 0.93. What is the ratio of the Expenditure(as % of GDP) in Sweden in 2007 to that in 2008?
Offer a terse response. 0.93. What is the ratio of the Expenditure(as % of GDP) in Euro area in 2007 to that in 2009?
Ensure brevity in your answer.  0.91. What is the ratio of the Expenditure(as % of GDP) of Korea (Republic) in 2007 to that in 2009?
Offer a terse response. 0.91. What is the ratio of the Expenditure(as % of GDP) of Poland in 2007 to that in 2009?
Your answer should be compact. 0.84. What is the ratio of the Expenditure(as % of GDP) in Sweden in 2007 to that in 2009?
Ensure brevity in your answer.  0.95. What is the ratio of the Expenditure(as % of GDP) of Euro area in 2007 to that in 2010?
Provide a succinct answer. 0.91. What is the ratio of the Expenditure(as % of GDP) in Korea (Republic) in 2007 to that in 2010?
Ensure brevity in your answer.  0.87. What is the ratio of the Expenditure(as % of GDP) in Poland in 2007 to that in 2010?
Offer a very short reply. 0.78. What is the ratio of the Expenditure(as % of GDP) of Sweden in 2007 to that in 2010?
Give a very brief answer. 1.01. What is the ratio of the Expenditure(as % of GDP) in Euro area in 2008 to that in 2009?
Your answer should be compact. 0.95. What is the ratio of the Expenditure(as % of GDP) in Korea (Republic) in 2008 to that in 2009?
Provide a short and direct response. 0.95. What is the ratio of the Expenditure(as % of GDP) of Poland in 2008 to that in 2009?
Make the answer very short. 0.91. What is the ratio of the Expenditure(as % of GDP) of Sweden in 2008 to that in 2009?
Your response must be concise. 1.02. What is the ratio of the Expenditure(as % of GDP) in Euro area in 2008 to that in 2010?
Keep it short and to the point. 0.95. What is the ratio of the Expenditure(as % of GDP) in Korea (Republic) in 2008 to that in 2010?
Keep it short and to the point. 0.9. What is the ratio of the Expenditure(as % of GDP) of Poland in 2008 to that in 2010?
Your answer should be compact. 0.83. What is the ratio of the Expenditure(as % of GDP) in Sweden in 2008 to that in 2010?
Keep it short and to the point. 1.09. What is the ratio of the Expenditure(as % of GDP) in Euro area in 2009 to that in 2010?
Make the answer very short. 1. What is the ratio of the Expenditure(as % of GDP) of Korea (Republic) in 2009 to that in 2010?
Your response must be concise. 0.95. What is the ratio of the Expenditure(as % of GDP) in Poland in 2009 to that in 2010?
Offer a very short reply. 0.92. What is the ratio of the Expenditure(as % of GDP) of Sweden in 2009 to that in 2010?
Give a very brief answer. 1.06. What is the difference between the highest and the second highest Expenditure(as % of GDP) of Euro area?
Offer a very short reply. 0.01. What is the difference between the highest and the second highest Expenditure(as % of GDP) of Korea (Republic)?
Make the answer very short. 0.17. What is the difference between the highest and the second highest Expenditure(as % of GDP) of Poland?
Provide a succinct answer. 0.06. What is the difference between the highest and the second highest Expenditure(as % of GDP) in Sweden?
Keep it short and to the point. 0.01. What is the difference between the highest and the lowest Expenditure(as % of GDP) in Euro area?
Offer a very short reply. 0.22. What is the difference between the highest and the lowest Expenditure(as % of GDP) in Korea (Republic)?
Ensure brevity in your answer.  0.93. What is the difference between the highest and the lowest Expenditure(as % of GDP) of Poland?
Keep it short and to the point. 0.17. What is the difference between the highest and the lowest Expenditure(as % of GDP) in Sweden?
Make the answer very short. 0.28. 